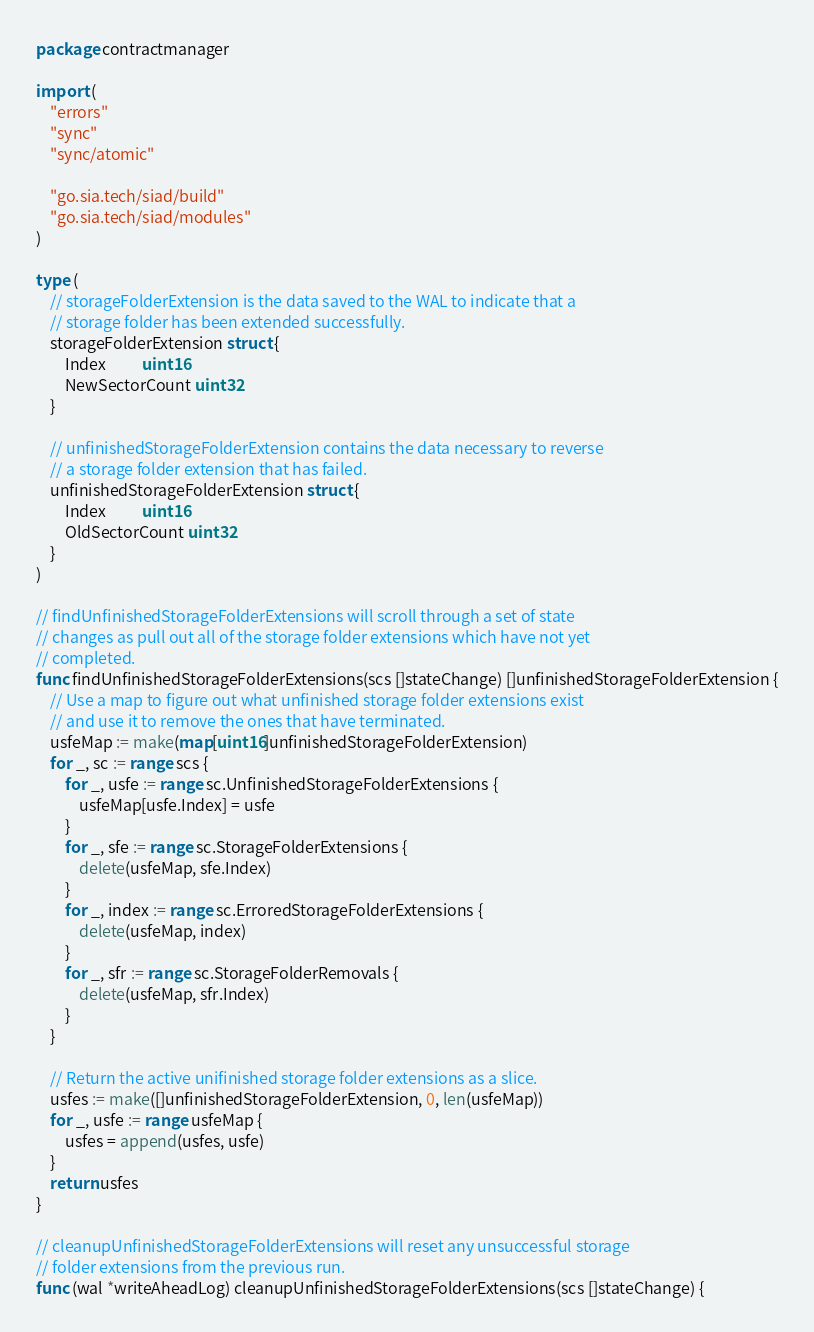<code> <loc_0><loc_0><loc_500><loc_500><_Go_>package contractmanager

import (
	"errors"
	"sync"
	"sync/atomic"

	"go.sia.tech/siad/build"
	"go.sia.tech/siad/modules"
)

type (
	// storageFolderExtension is the data saved to the WAL to indicate that a
	// storage folder has been extended successfully.
	storageFolderExtension struct {
		Index          uint16
		NewSectorCount uint32
	}

	// unfinishedStorageFolderExtension contains the data necessary to reverse
	// a storage folder extension that has failed.
	unfinishedStorageFolderExtension struct {
		Index          uint16
		OldSectorCount uint32
	}
)

// findUnfinishedStorageFolderExtensions will scroll through a set of state
// changes as pull out all of the storage folder extensions which have not yet
// completed.
func findUnfinishedStorageFolderExtensions(scs []stateChange) []unfinishedStorageFolderExtension {
	// Use a map to figure out what unfinished storage folder extensions exist
	// and use it to remove the ones that have terminated.
	usfeMap := make(map[uint16]unfinishedStorageFolderExtension)
	for _, sc := range scs {
		for _, usfe := range sc.UnfinishedStorageFolderExtensions {
			usfeMap[usfe.Index] = usfe
		}
		for _, sfe := range sc.StorageFolderExtensions {
			delete(usfeMap, sfe.Index)
		}
		for _, index := range sc.ErroredStorageFolderExtensions {
			delete(usfeMap, index)
		}
		for _, sfr := range sc.StorageFolderRemovals {
			delete(usfeMap, sfr.Index)
		}
	}

	// Return the active unifinished storage folder extensions as a slice.
	usfes := make([]unfinishedStorageFolderExtension, 0, len(usfeMap))
	for _, usfe := range usfeMap {
		usfes = append(usfes, usfe)
	}
	return usfes
}

// cleanupUnfinishedStorageFolderExtensions will reset any unsuccessful storage
// folder extensions from the previous run.
func (wal *writeAheadLog) cleanupUnfinishedStorageFolderExtensions(scs []stateChange) {</code> 